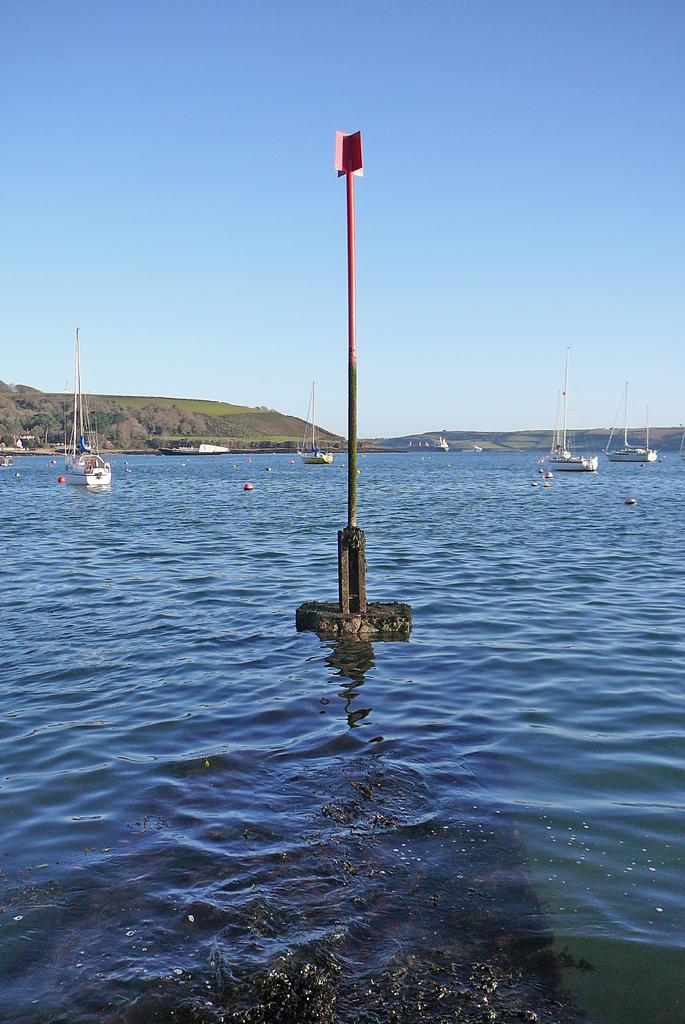What is in the water in the image? There is a pole in the water. What else can be seen on the water's surface? There are boats floating on the water. What is visible in the background of the image? The sky is visible in the background of the image. Are there any giants visible in the image? There are no giants present in the image. What type of art can be seen in the image? There is no art present in the image; it features a pole in the water, boats floating on the water, and the sky in the background. 